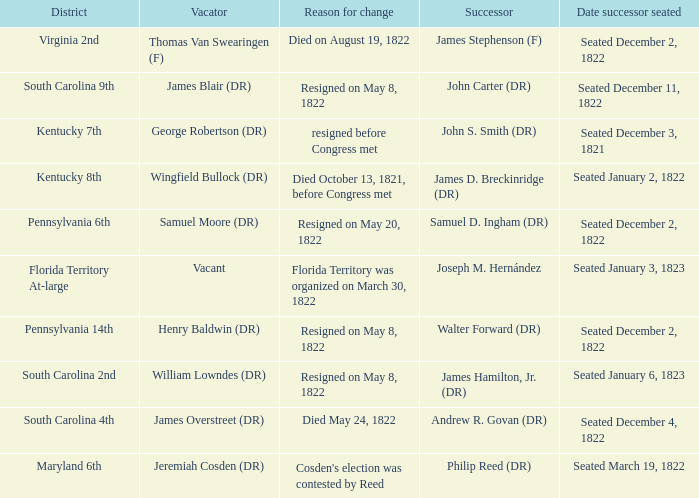What is the reason for change when maryland 6th is the district?  Cosden's election was contested by Reed. 